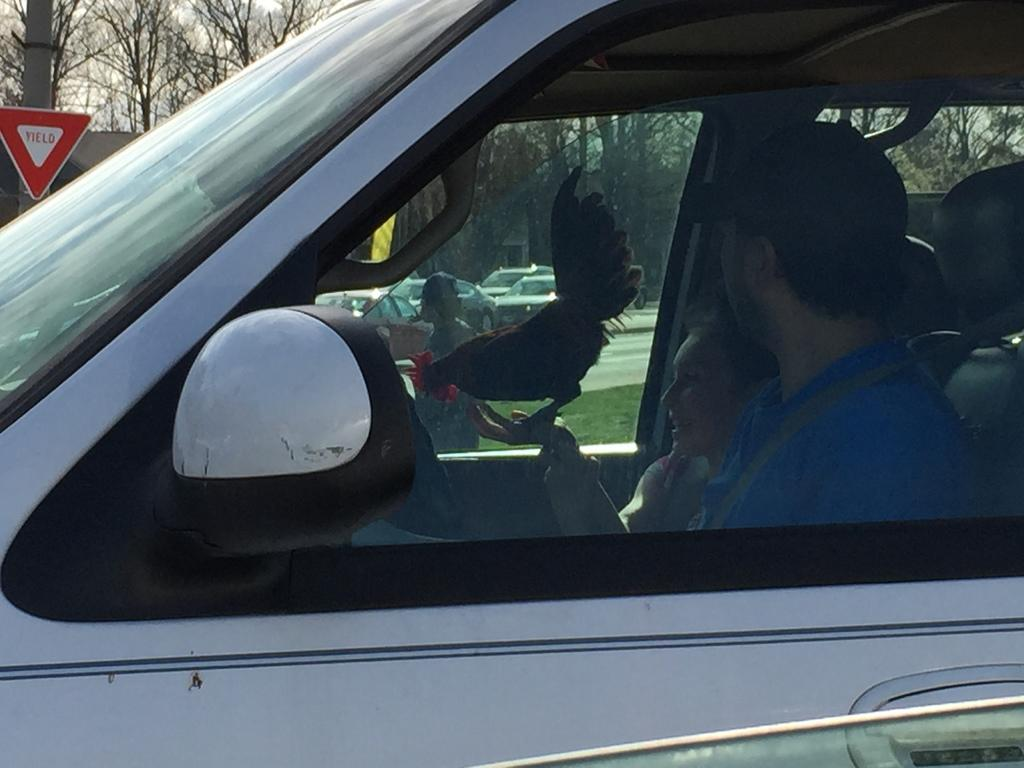What are the two people in the image doing? The two people are sitting on a vehicle in the bottom right side of the image. What is located in the middle of the image? There is a hen in the middle of the image. What can be seen in the top left side of the image? There are trees and a pole in the top left side of the image. What type of clouds can be seen in the image? There are no clouds visible in the image. What cord is connected to the hen in the image? There is no cord connected to the hen in the image. 